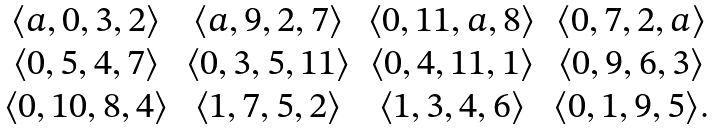<formula> <loc_0><loc_0><loc_500><loc_500>\begin{array} { c c c c } \langle a , 0 , 3 , 2 \rangle & \langle a , 9 , 2 , 7 \rangle & \langle 0 , 1 1 , a , 8 \rangle & \langle 0 , 7 , 2 , a \rangle \\ \langle 0 , 5 , 4 , 7 \rangle & \langle 0 , 3 , 5 , 1 1 \rangle & \langle 0 , 4 , 1 1 , 1 \rangle & \langle 0 , 9 , 6 , 3 \rangle \\ \langle 0 , 1 0 , 8 , 4 \rangle & \langle 1 , 7 , 5 , 2 \rangle & \langle 1 , 3 , 4 , 6 \rangle & \langle 0 , 1 , 9 , 5 \rangle . \\ \end{array}</formula> 